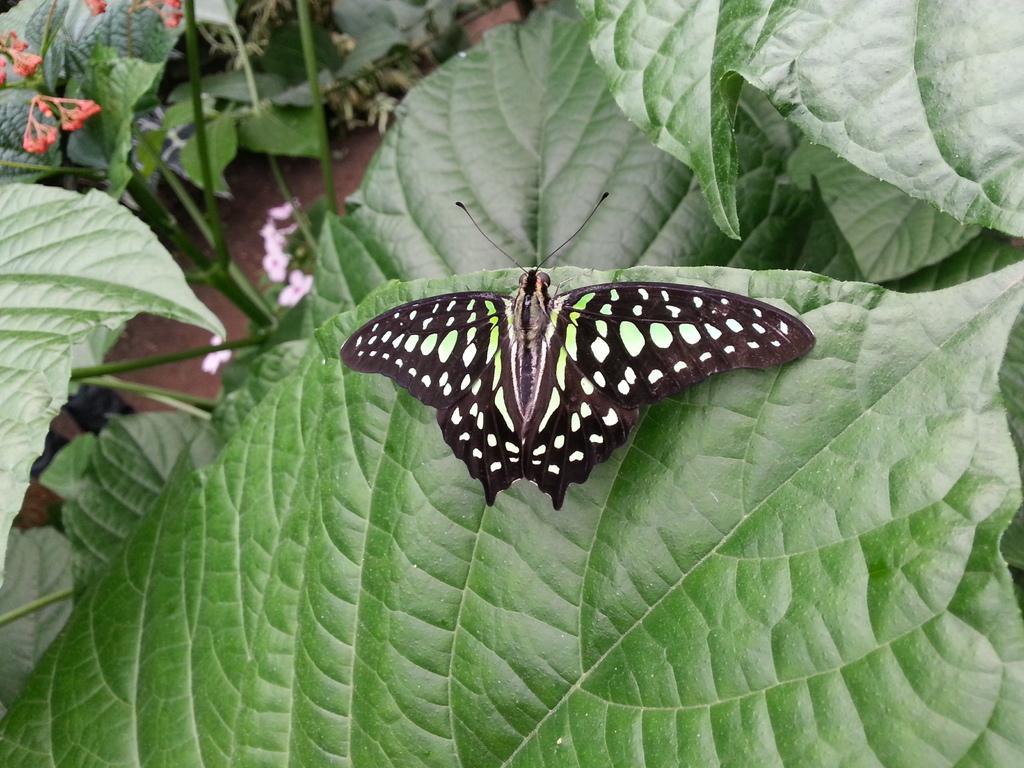How would you summarize this image in a sentence or two? In this picture we can see a butterfly on the leaf and in front of the leaf there are plants. 